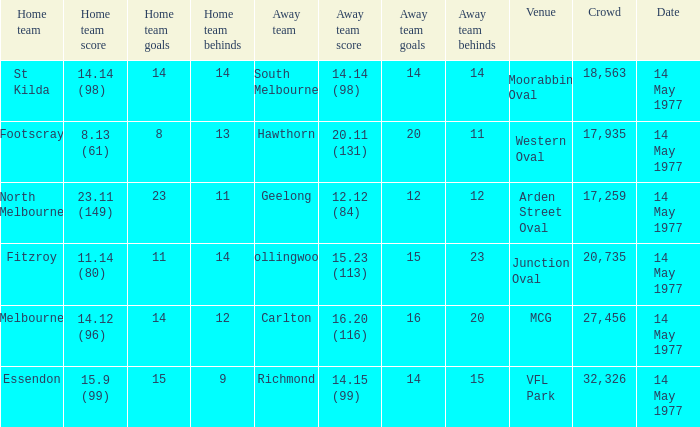How many people were in the crowd with the away team being collingwood? 1.0. 